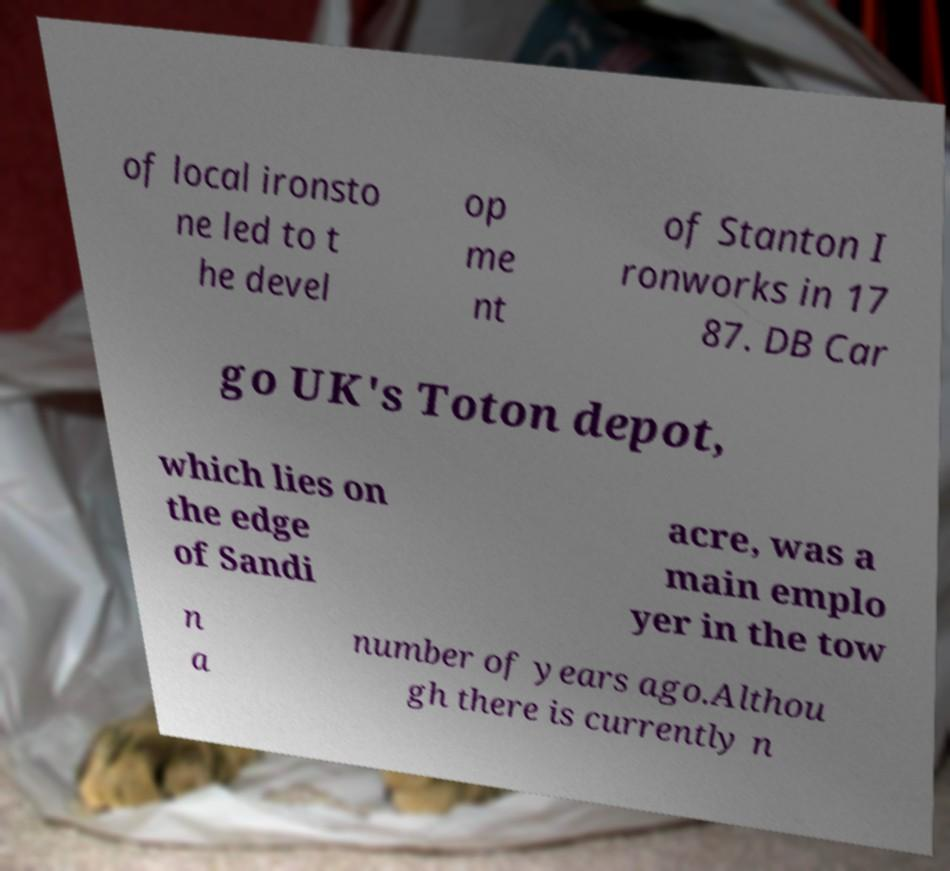For documentation purposes, I need the text within this image transcribed. Could you provide that? of local ironsto ne led to t he devel op me nt of Stanton I ronworks in 17 87. DB Car go UK's Toton depot, which lies on the edge of Sandi acre, was a main emplo yer in the tow n a number of years ago.Althou gh there is currently n 